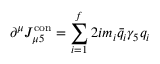Convert formula to latex. <formula><loc_0><loc_0><loc_500><loc_500>\partial ^ { \mu } J _ { \mu 5 } ^ { c o n } = \sum _ { i = 1 } ^ { f } 2 i m _ { i } \bar { q } _ { i } \gamma _ { 5 } q _ { i }</formula> 